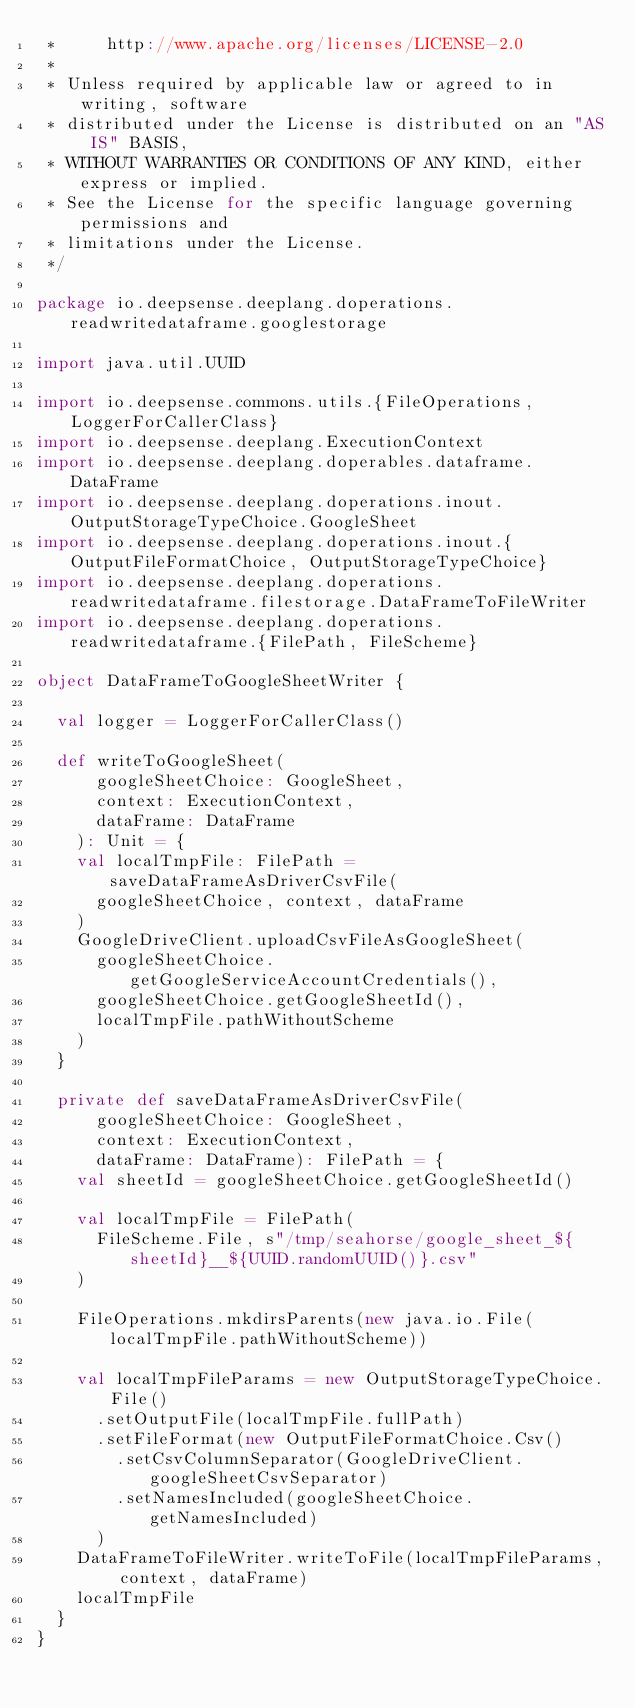<code> <loc_0><loc_0><loc_500><loc_500><_Scala_> *     http://www.apache.org/licenses/LICENSE-2.0
 *
 * Unless required by applicable law or agreed to in writing, software
 * distributed under the License is distributed on an "AS IS" BASIS,
 * WITHOUT WARRANTIES OR CONDITIONS OF ANY KIND, either express or implied.
 * See the License for the specific language governing permissions and
 * limitations under the License.
 */

package io.deepsense.deeplang.doperations.readwritedataframe.googlestorage

import java.util.UUID

import io.deepsense.commons.utils.{FileOperations, LoggerForCallerClass}
import io.deepsense.deeplang.ExecutionContext
import io.deepsense.deeplang.doperables.dataframe.DataFrame
import io.deepsense.deeplang.doperations.inout.OutputStorageTypeChoice.GoogleSheet
import io.deepsense.deeplang.doperations.inout.{OutputFileFormatChoice, OutputStorageTypeChoice}
import io.deepsense.deeplang.doperations.readwritedataframe.filestorage.DataFrameToFileWriter
import io.deepsense.deeplang.doperations.readwritedataframe.{FilePath, FileScheme}

object DataFrameToGoogleSheetWriter {

  val logger = LoggerForCallerClass()

  def writeToGoogleSheet(
      googleSheetChoice: GoogleSheet,
      context: ExecutionContext,
      dataFrame: DataFrame
    ): Unit = {
    val localTmpFile: FilePath = saveDataFrameAsDriverCsvFile(
      googleSheetChoice, context, dataFrame
    )
    GoogleDriveClient.uploadCsvFileAsGoogleSheet(
      googleSheetChoice.getGoogleServiceAccountCredentials(),
      googleSheetChoice.getGoogleSheetId(),
      localTmpFile.pathWithoutScheme
    )
  }

  private def saveDataFrameAsDriverCsvFile(
      googleSheetChoice: GoogleSheet,
      context: ExecutionContext,
      dataFrame: DataFrame): FilePath = {
    val sheetId = googleSheetChoice.getGoogleSheetId()

    val localTmpFile = FilePath(
      FileScheme.File, s"/tmp/seahorse/google_sheet_${sheetId}__${UUID.randomUUID()}.csv"
    )

    FileOperations.mkdirsParents(new java.io.File(localTmpFile.pathWithoutScheme))

    val localTmpFileParams = new OutputStorageTypeChoice.File()
      .setOutputFile(localTmpFile.fullPath)
      .setFileFormat(new OutputFileFormatChoice.Csv()
        .setCsvColumnSeparator(GoogleDriveClient.googleSheetCsvSeparator)
        .setNamesIncluded(googleSheetChoice.getNamesIncluded)
      )
    DataFrameToFileWriter.writeToFile(localTmpFileParams, context, dataFrame)
    localTmpFile
  }
}
</code> 